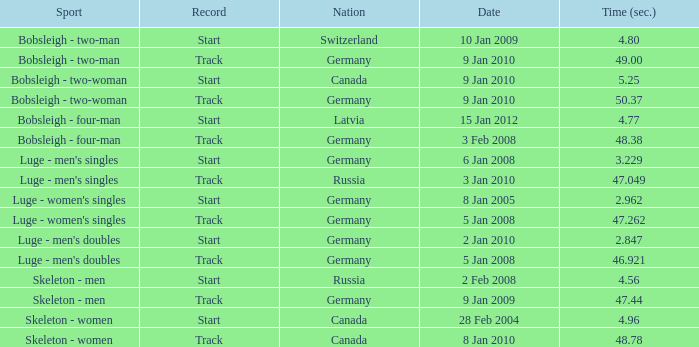Which nation finished with a time of 47.049? Russia. 